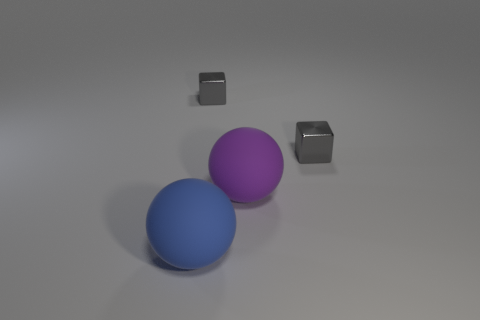Does this image seem to represent a realistic scene? The image presents a stylized scene rather than a realistic one. This is suggested by the simplistic combination of objects with perfectly smooth surfaces and uniform colors, set against a neutral background. In reality, objects usually show some degree of texture, wear, and varying shades. 